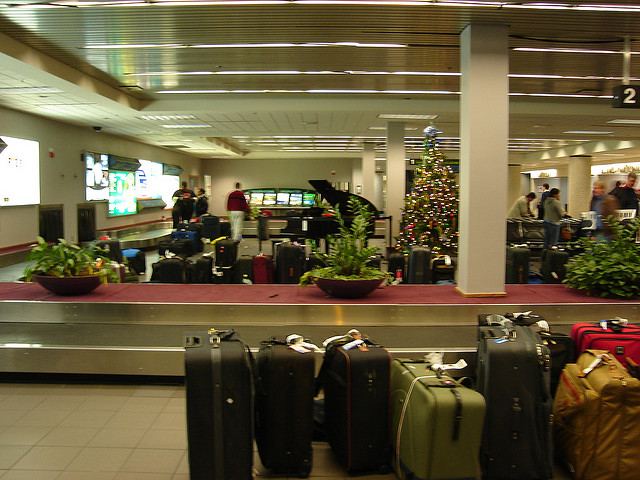<image>What season is it? It is ambiguous to determine the season. It could be either winter or fall or Christmas season. What season is it? I'm not sure what season it is. It could be either holiday season, Christmas, winter or fall. 